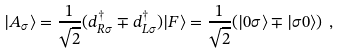Convert formula to latex. <formula><loc_0><loc_0><loc_500><loc_500>| A _ { \sigma } \rangle = \frac { 1 } { \sqrt { 2 } } ( d ^ { \dag } _ { R \sigma } \mp d ^ { \dag } _ { L \sigma } ) | F \rangle = \frac { 1 } { \sqrt { 2 } } ( | 0 \sigma \rangle \mp | \sigma 0 \rangle ) \ ,</formula> 